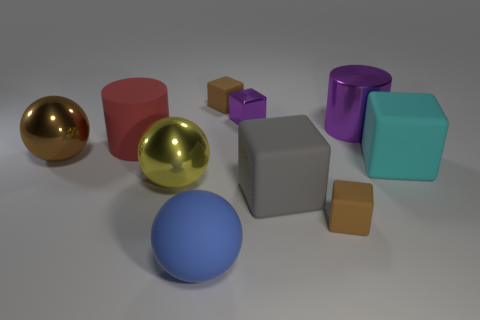Subtract all tiny purple metal cubes. How many cubes are left? 4 Subtract all brown balls. How many balls are left? 2 Subtract all cylinders. How many objects are left? 8 Subtract all cyan cylinders. How many cyan blocks are left? 1 Subtract all large brown balls. Subtract all tiny metal objects. How many objects are left? 8 Add 5 tiny objects. How many tiny objects are left? 8 Add 10 small purple cylinders. How many small purple cylinders exist? 10 Subtract 1 yellow balls. How many objects are left? 9 Subtract 1 spheres. How many spheres are left? 2 Subtract all gray blocks. Subtract all green cylinders. How many blocks are left? 4 